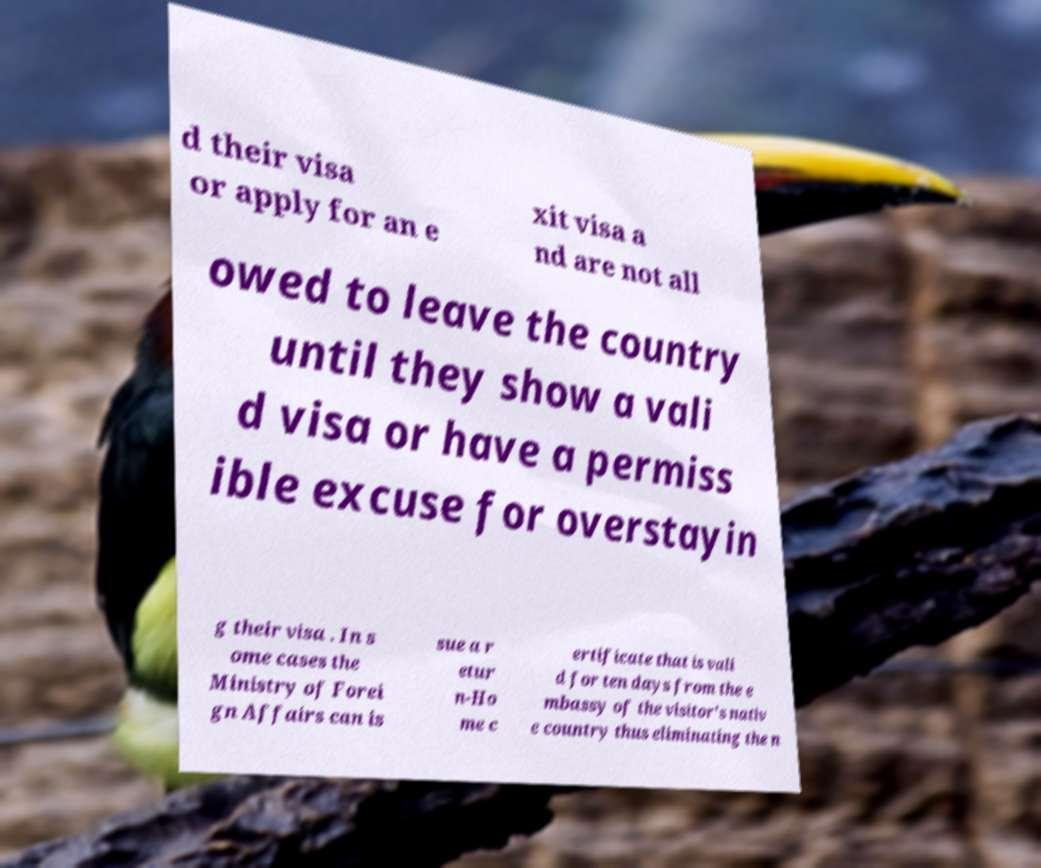Please read and relay the text visible in this image. What does it say? d their visa or apply for an e xit visa a nd are not all owed to leave the country until they show a vali d visa or have a permiss ible excuse for overstayin g their visa . In s ome cases the Ministry of Forei gn Affairs can is sue a r etur n-Ho me c ertificate that is vali d for ten days from the e mbassy of the visitor's nativ e country thus eliminating the n 